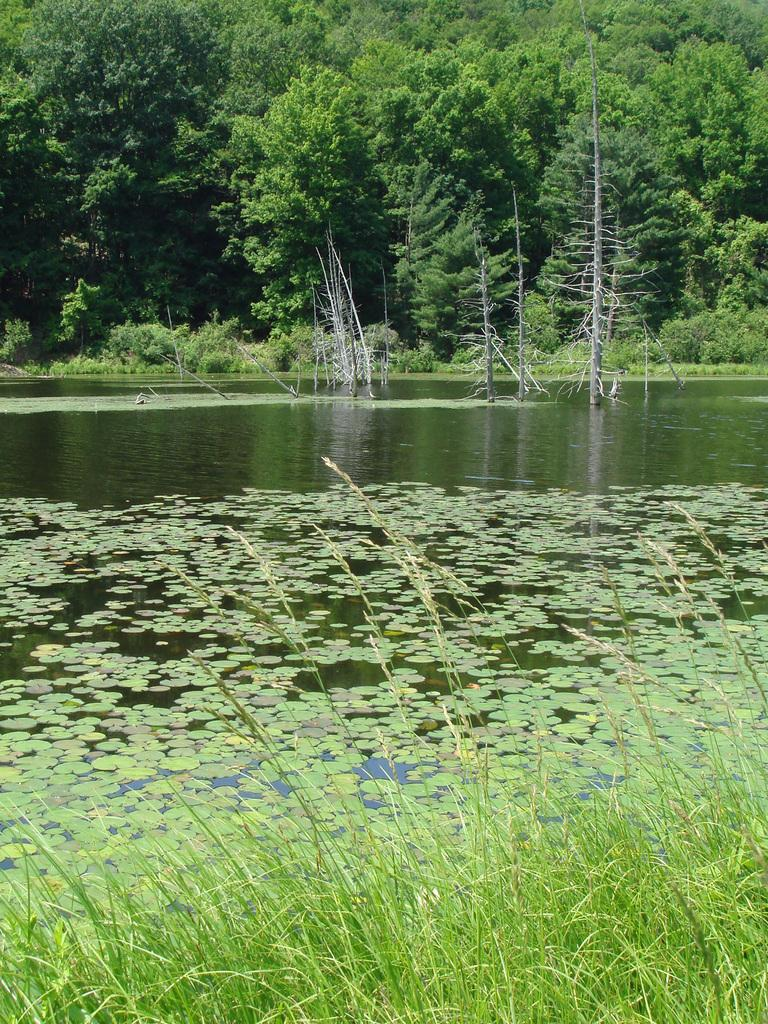What type of vegetation is on the ground in the image? There is grass on the ground in the image. What can be seen in the water in the background? There are plants and trees in the water in the background. What other types of vegetation are visible in the background? There are trees and plants on the ground in the background. Can you tell me how many coils are present in the image? There are no coils present in the image. What type of legal advice is being given in the image? There is no lawyer or legal advice present in the image. 